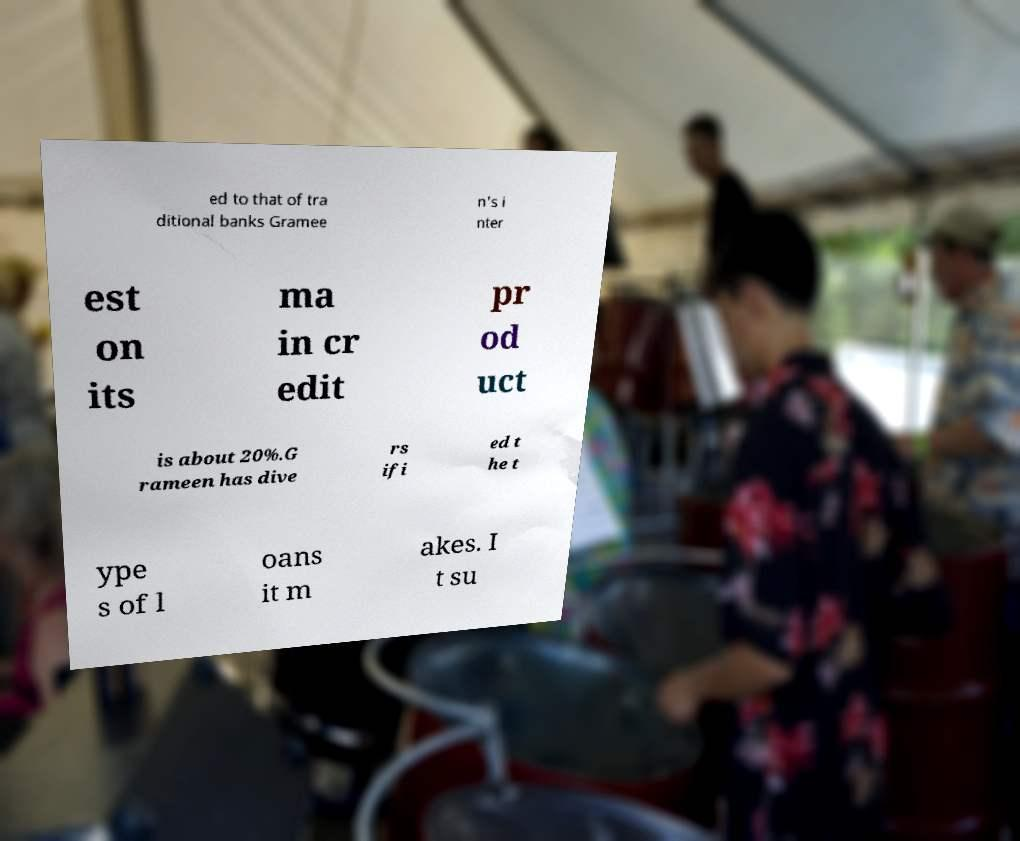What messages or text are displayed in this image? I need them in a readable, typed format. ed to that of tra ditional banks Gramee n's i nter est on its ma in cr edit pr od uct is about 20%.G rameen has dive rs ifi ed t he t ype s of l oans it m akes. I t su 